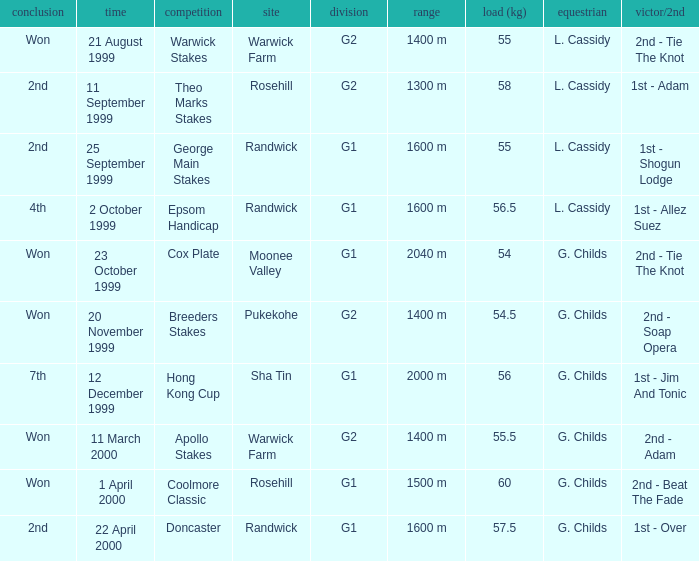List the weight for 56.5 kilograms. Epsom Handicap. 